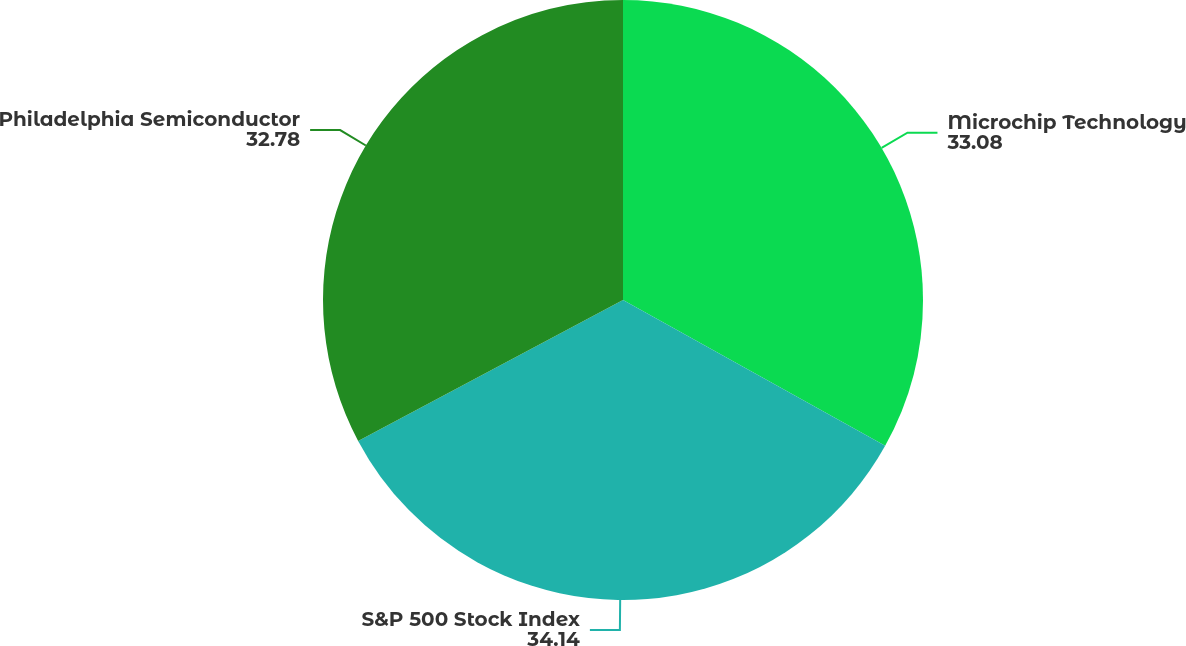<chart> <loc_0><loc_0><loc_500><loc_500><pie_chart><fcel>Microchip Technology<fcel>S&P 500 Stock Index<fcel>Philadelphia Semiconductor<nl><fcel>33.08%<fcel>34.14%<fcel>32.78%<nl></chart> 